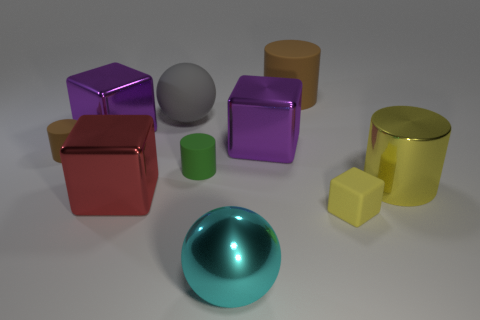How many brown cylinders must be subtracted to get 1 brown cylinders? 1 Subtract all green cylinders. How many cylinders are left? 3 Subtract 0 gray cylinders. How many objects are left? 10 Subtract all balls. How many objects are left? 8 Subtract 3 cylinders. How many cylinders are left? 1 Subtract all green cylinders. Subtract all yellow balls. How many cylinders are left? 3 Subtract all green cylinders. How many yellow cubes are left? 1 Subtract all big balls. Subtract all yellow matte things. How many objects are left? 7 Add 2 shiny spheres. How many shiny spheres are left? 3 Add 7 big purple matte cubes. How many big purple matte cubes exist? 7 